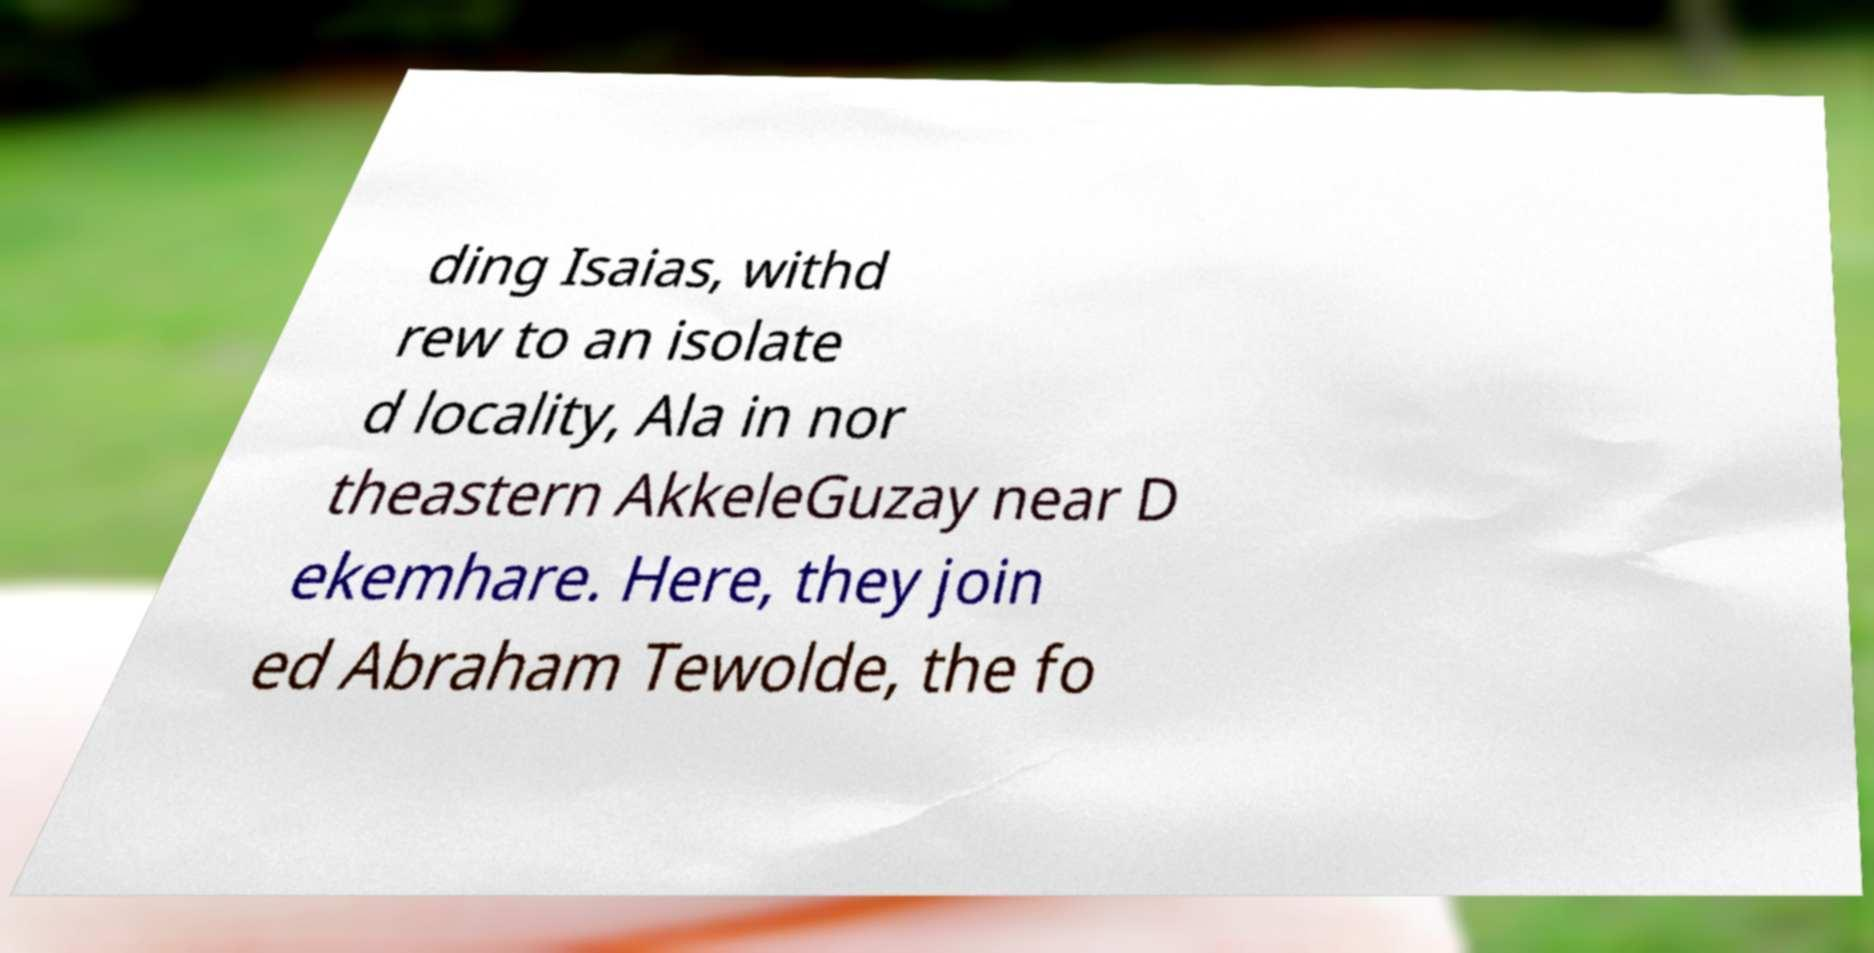I need the written content from this picture converted into text. Can you do that? ding Isaias, withd rew to an isolate d locality, Ala in nor theastern AkkeleGuzay near D ekemhare. Here, they join ed Abraham Tewolde, the fo 